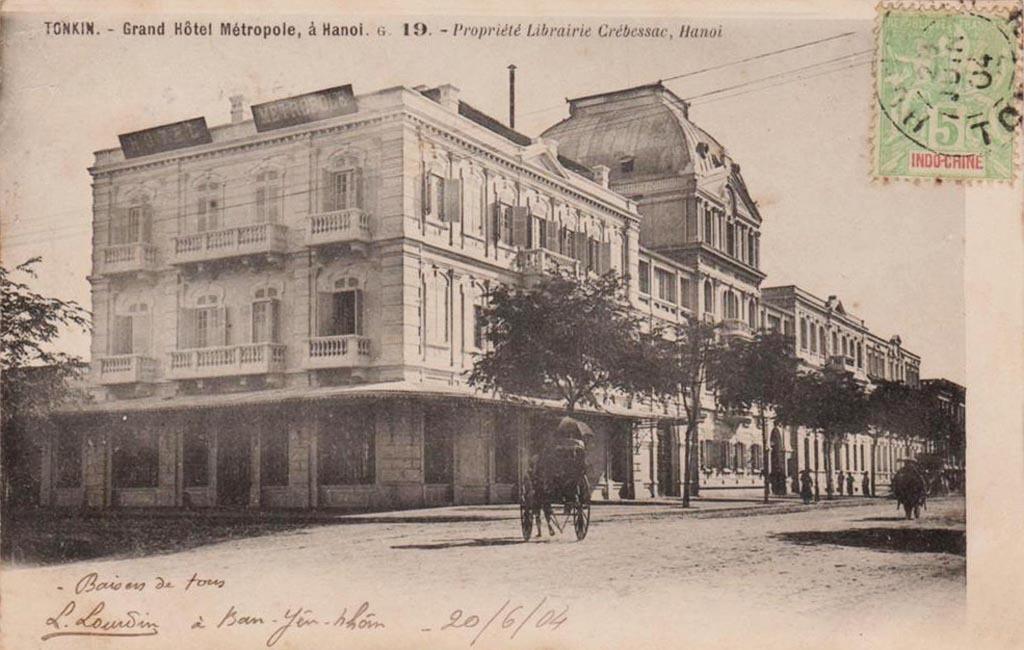Please provide a concise description of this image. In this picture we can see a poster, in the poster we can see few buildings, trees, few people and a cart, at the top and bottom of the image we can find some text, in the top right hand corner we can see a stamp. 